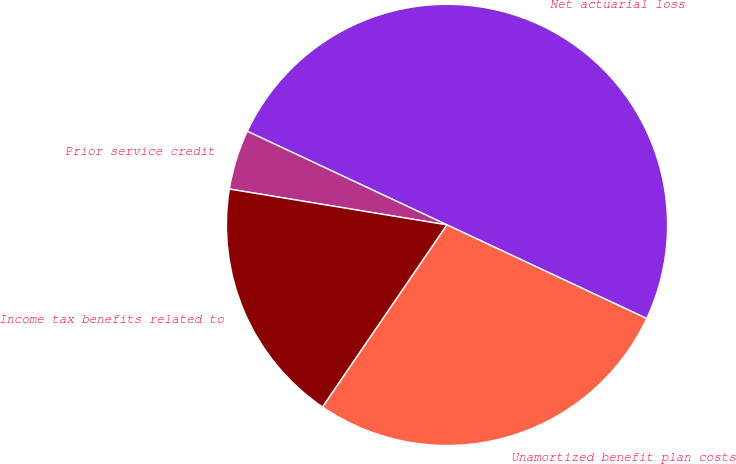Convert chart to OTSL. <chart><loc_0><loc_0><loc_500><loc_500><pie_chart><fcel>Net actuarial loss<fcel>Prior service credit<fcel>Income tax benefits related to<fcel>Unamortized benefit plan costs<nl><fcel>50.0%<fcel>4.38%<fcel>18.06%<fcel>27.56%<nl></chart> 